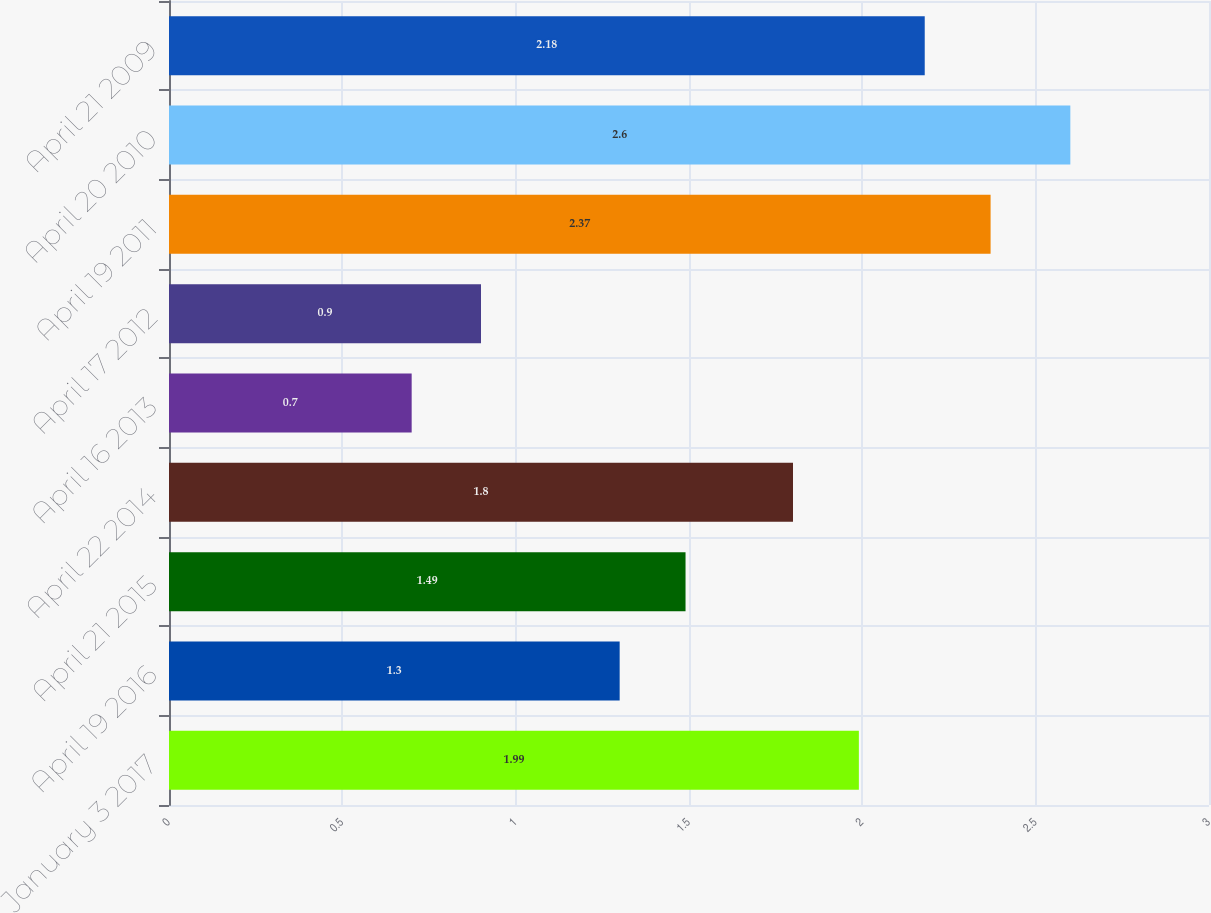Convert chart. <chart><loc_0><loc_0><loc_500><loc_500><bar_chart><fcel>January 3 2017<fcel>April 19 2016<fcel>April 21 2015<fcel>April 22 2014<fcel>April 16 2013<fcel>April 17 2012<fcel>April 19 2011<fcel>April 20 2010<fcel>April 21 2009<nl><fcel>1.99<fcel>1.3<fcel>1.49<fcel>1.8<fcel>0.7<fcel>0.9<fcel>2.37<fcel>2.6<fcel>2.18<nl></chart> 